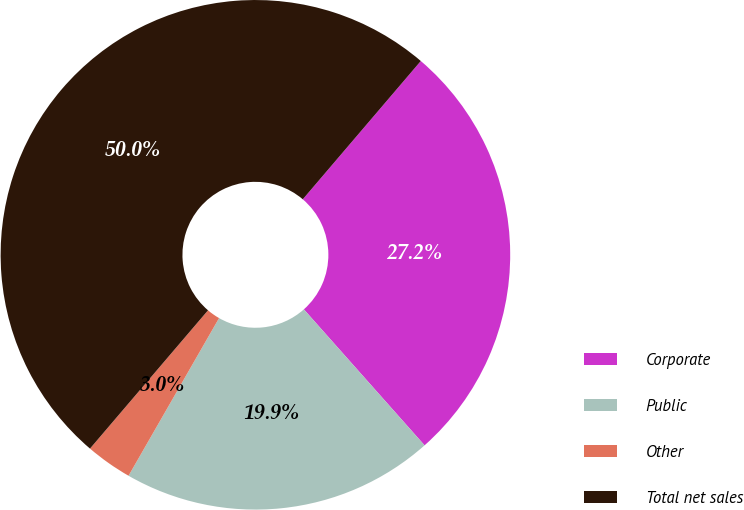Convert chart. <chart><loc_0><loc_0><loc_500><loc_500><pie_chart><fcel>Corporate<fcel>Public<fcel>Other<fcel>Total net sales<nl><fcel>27.2%<fcel>19.85%<fcel>2.95%<fcel>50.0%<nl></chart> 